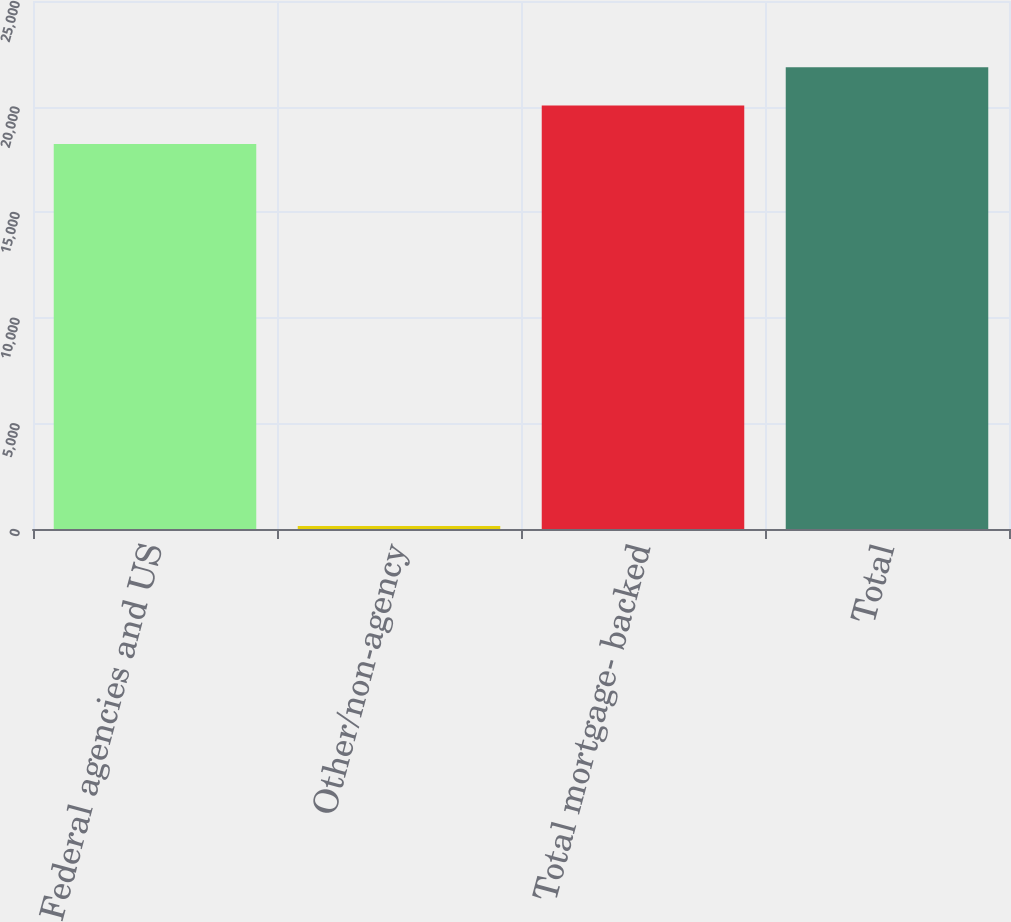Convert chart to OTSL. <chart><loc_0><loc_0><loc_500><loc_500><bar_chart><fcel>Federal agencies and US<fcel>Other/non-agency<fcel>Total mortgage- backed<fcel>Total<nl><fcel>18224<fcel>139<fcel>20046.4<fcel>21868.8<nl></chart> 